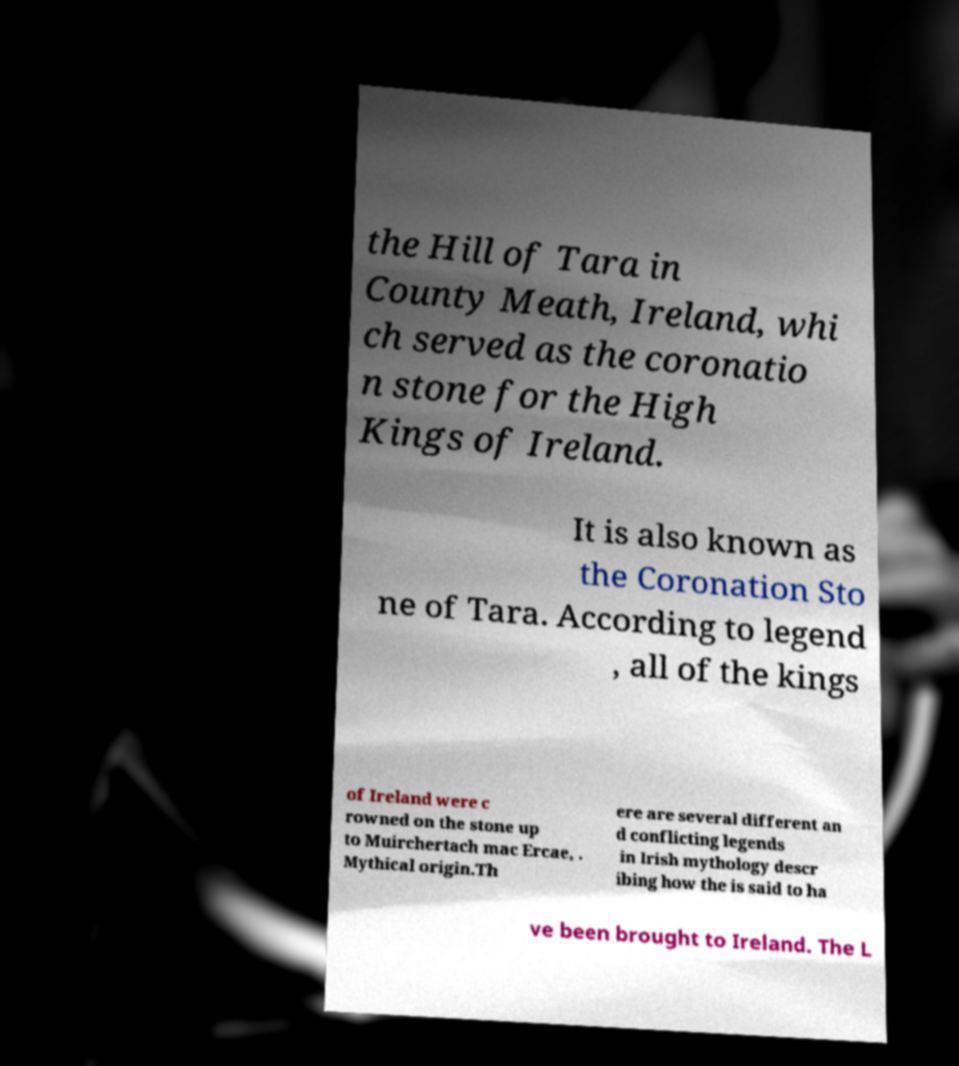I need the written content from this picture converted into text. Can you do that? the Hill of Tara in County Meath, Ireland, whi ch served as the coronatio n stone for the High Kings of Ireland. It is also known as the Coronation Sto ne of Tara. According to legend , all of the kings of Ireland were c rowned on the stone up to Muirchertach mac Ercae, . Mythical origin.Th ere are several different an d conflicting legends in Irish mythology descr ibing how the is said to ha ve been brought to Ireland. The L 